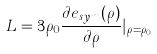Convert formula to latex. <formula><loc_0><loc_0><loc_500><loc_500>L = 3 \rho _ { 0 } \frac { \partial e _ { s y m } ( \rho ) } { \partial \rho } | _ { \rho = \rho _ { 0 } }</formula> 